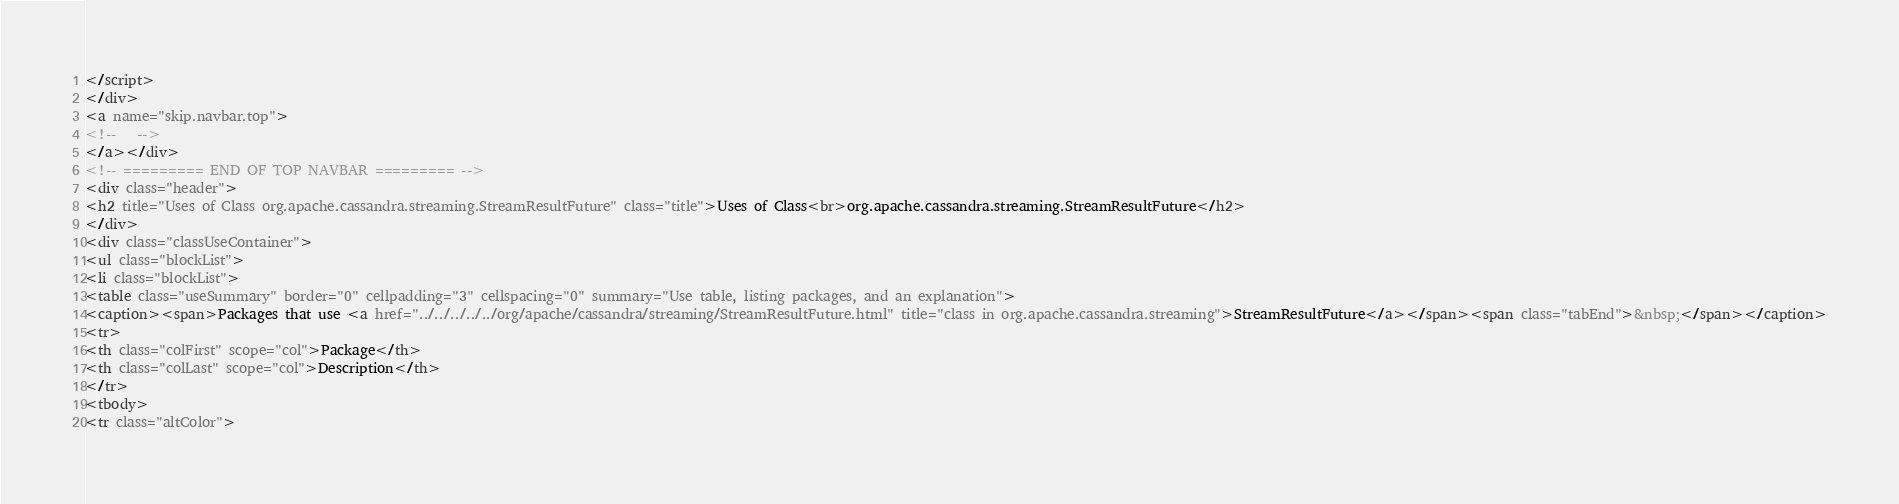<code> <loc_0><loc_0><loc_500><loc_500><_HTML_></script>
</div>
<a name="skip.navbar.top">
<!--   -->
</a></div>
<!-- ========= END OF TOP NAVBAR ========= -->
<div class="header">
<h2 title="Uses of Class org.apache.cassandra.streaming.StreamResultFuture" class="title">Uses of Class<br>org.apache.cassandra.streaming.StreamResultFuture</h2>
</div>
<div class="classUseContainer">
<ul class="blockList">
<li class="blockList">
<table class="useSummary" border="0" cellpadding="3" cellspacing="0" summary="Use table, listing packages, and an explanation">
<caption><span>Packages that use <a href="../../../../../org/apache/cassandra/streaming/StreamResultFuture.html" title="class in org.apache.cassandra.streaming">StreamResultFuture</a></span><span class="tabEnd">&nbsp;</span></caption>
<tr>
<th class="colFirst" scope="col">Package</th>
<th class="colLast" scope="col">Description</th>
</tr>
<tbody>
<tr class="altColor"></code> 